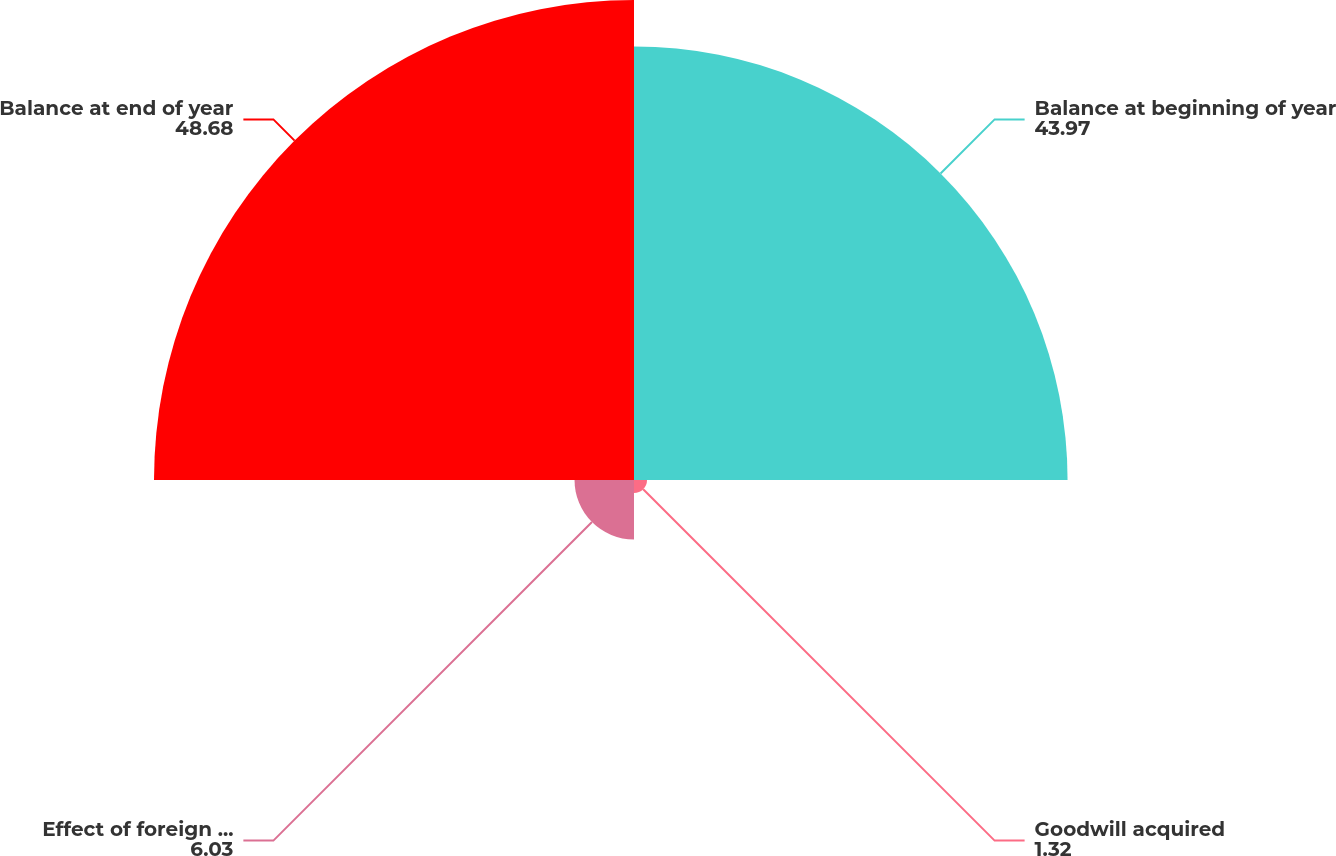<chart> <loc_0><loc_0><loc_500><loc_500><pie_chart><fcel>Balance at beginning of year<fcel>Goodwill acquired<fcel>Effect of foreign currency<fcel>Balance at end of year<nl><fcel>43.97%<fcel>1.32%<fcel>6.03%<fcel>48.68%<nl></chart> 